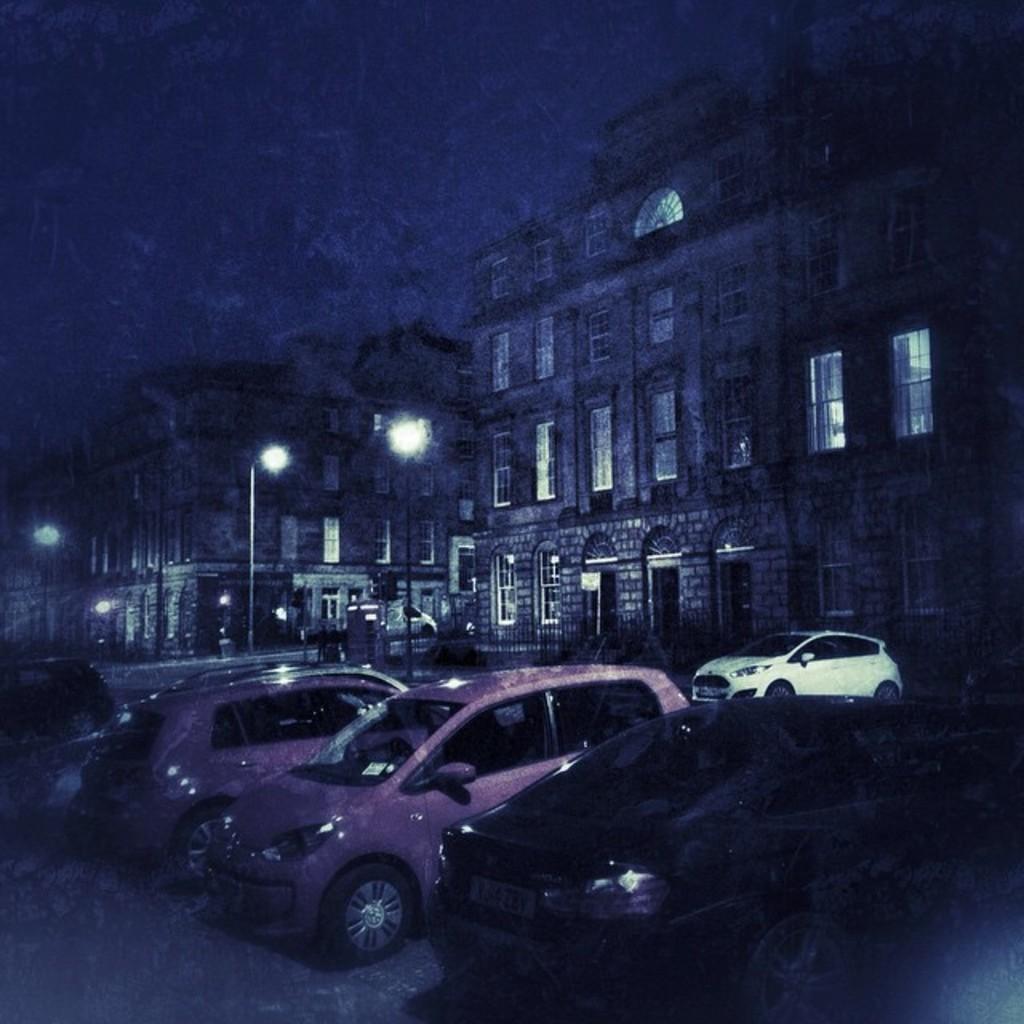In one or two sentences, can you explain what this image depicts? On the bottom we can see cars which are parked on the parking. Here we can see another car which is in white color park near to the building. Here we can see street lights near to the road. On the top we can see sky. Here we can see many windows on the building. 